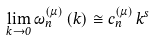Convert formula to latex. <formula><loc_0><loc_0><loc_500><loc_500>\lim _ { k \rightarrow 0 } \omega _ { n } ^ { ( \mu ) } \left ( k \right ) \cong c _ { n } ^ { ( \mu ) } \, k ^ { s }</formula> 